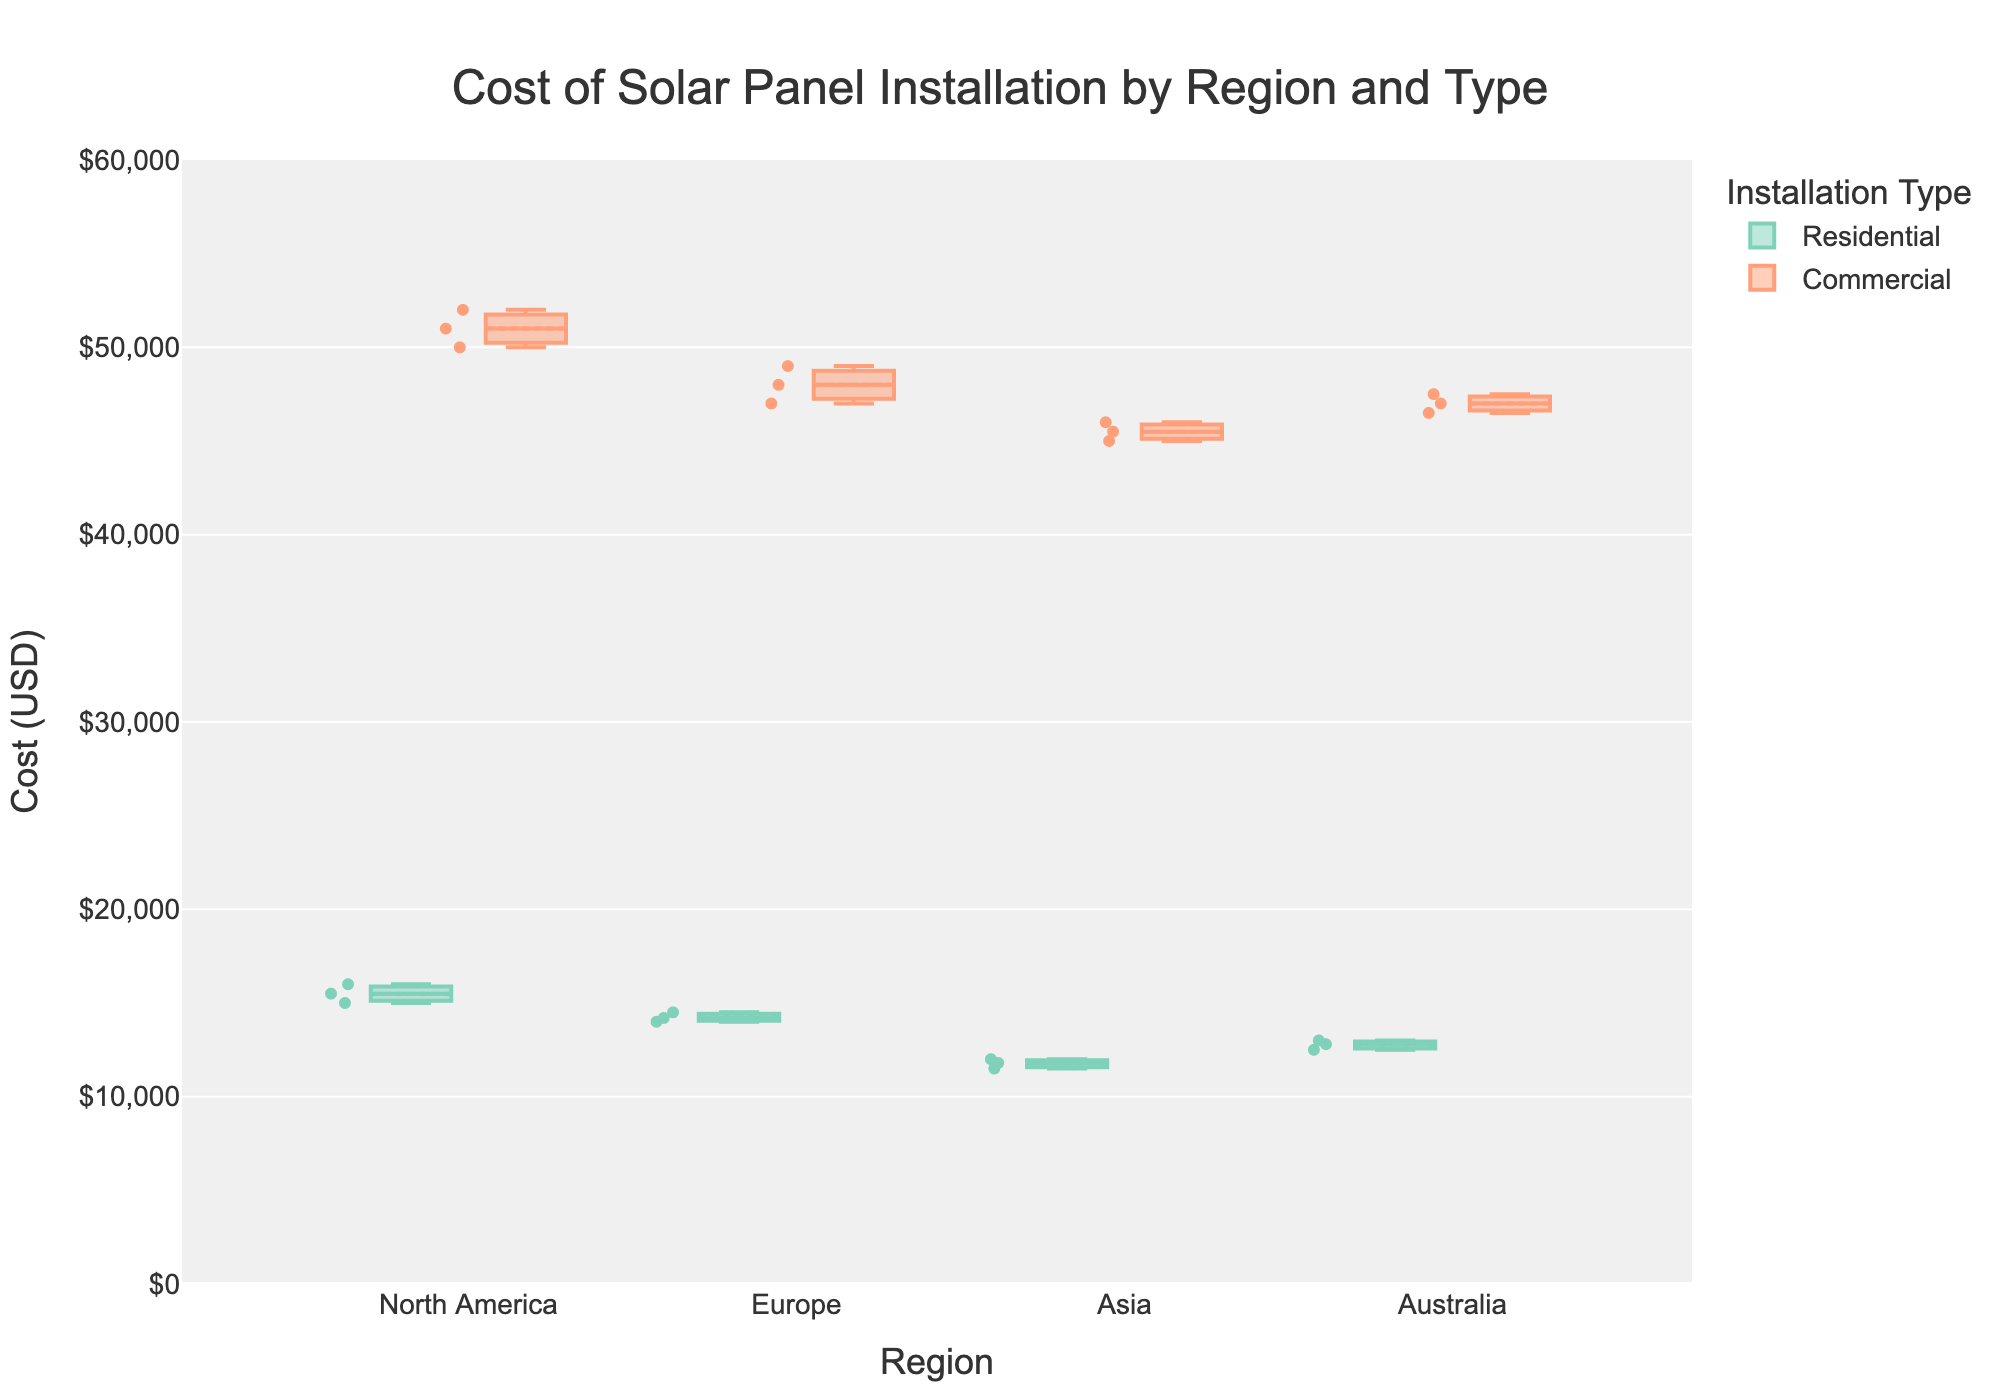What is the title of the figure? The title is clearly displayed at the top center of the figure.
Answer: Cost of Solar Panel Installation by Region and Type What is the y-axis representing? The y-axis label directly specifies what it represents.
Answer: Cost (USD) Which region has the lowest median cost for residential installations? By looking at the median line (middle line within the box) of the residential installations for each region, we can compare them.
Answer: Asia What color represents commercial installations? The legend indicates the color codes for installation types. The color for commercial installations is specified in the legend.
Answer: Orange How does the interquartile range (IQR) for residential installations in North America compare with that in Europe? The IQR is the range between the first quartile (bottom of the box) and the third quartile (top of the box). Compare the heights of the boxes for North America and Europe in the residential category.
Answer: North America's IQR is larger than Europe's IQR for residential installations Which region has the most consistent cost for commercial installations? Consistency of cost can be interpreted from the box plot as a smaller IQR. Compare the IQRs of the commercial installations across regions to identify the smallest one.
Answer: Asia Is there any overlap in the cost range of commercial installations between North America and Europe? Overlap can be observed by comparing the range of values shown by the whiskers (lines extending from the boxes) or data points for both regions.
Answer: Yes Are there any regions where the upper whisker or outliers of residential installations overlap with the lower whisker or outliers of commercial installations? Checking if ranges (whiskers or outliers) of residential installations in any region intersect with those of commercial installations.
Answer: No What is the median cost of residential installations in Australia? The median cost is represented by the middle line inside the box for residential installations in Australia.
Answer: 12800 USD 